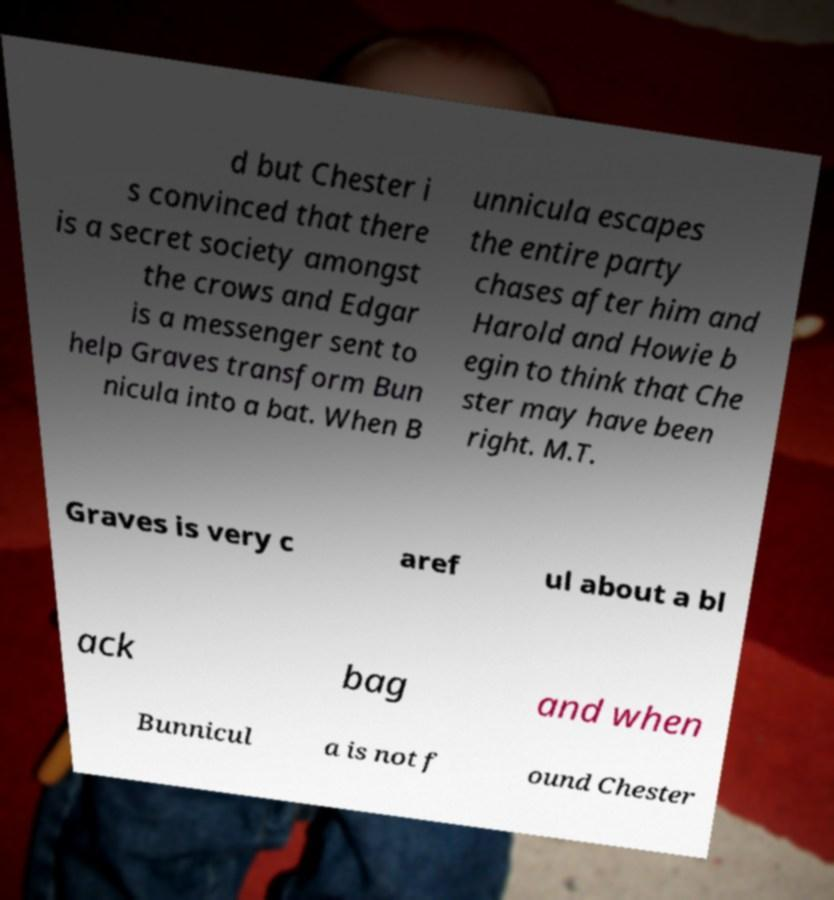For documentation purposes, I need the text within this image transcribed. Could you provide that? d but Chester i s convinced that there is a secret society amongst the crows and Edgar is a messenger sent to help Graves transform Bun nicula into a bat. When B unnicula escapes the entire party chases after him and Harold and Howie b egin to think that Che ster may have been right. M.T. Graves is very c aref ul about a bl ack bag and when Bunnicul a is not f ound Chester 